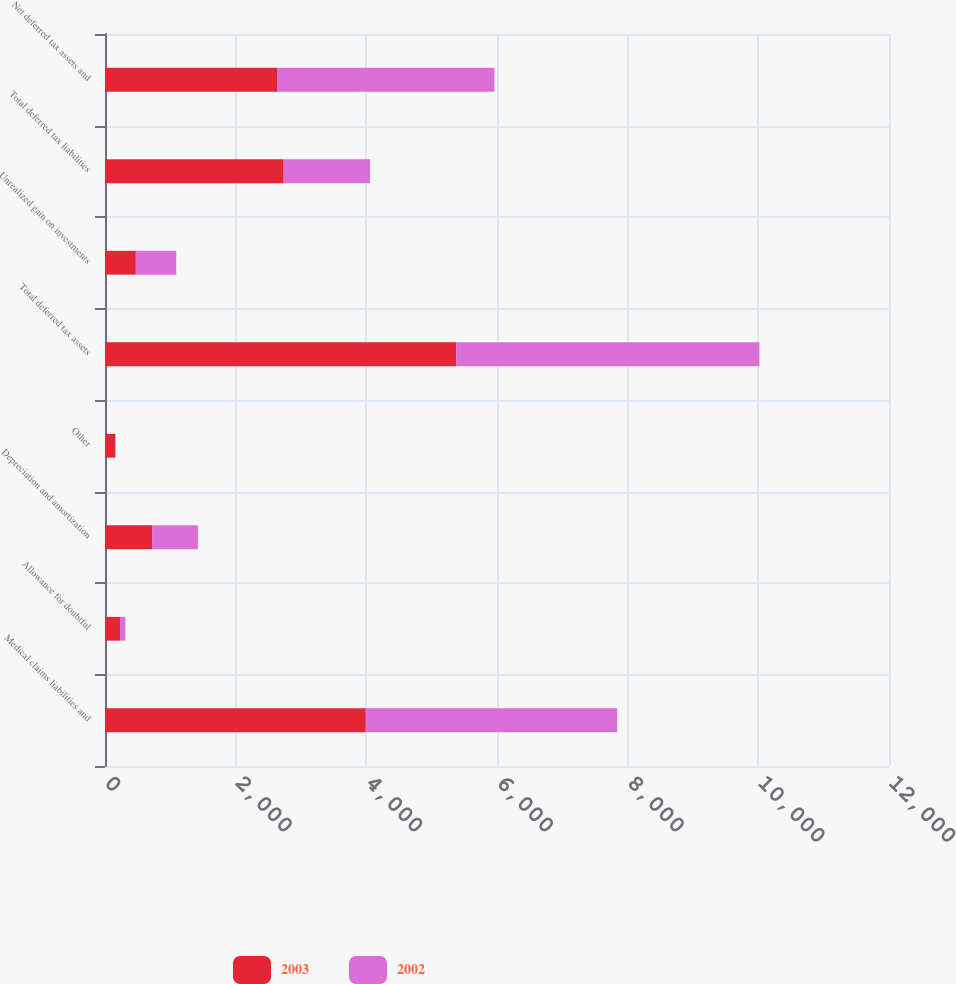<chart> <loc_0><loc_0><loc_500><loc_500><stacked_bar_chart><ecel><fcel>Medical claims liabilities and<fcel>Allowance for doubtful<fcel>Depreciation and amortization<fcel>Other<fcel>Total deferred tax assets<fcel>Unrealized gain on investments<fcel>Total deferred tax liabilities<fcel>Net deferred tax assets and<nl><fcel>2003<fcel>3992<fcel>230<fcel>720<fcel>156<fcel>5377<fcel>472<fcel>2735<fcel>2642<nl><fcel>2002<fcel>3848<fcel>81<fcel>702<fcel>8<fcel>4639<fcel>618<fcel>1321<fcel>3318<nl></chart> 